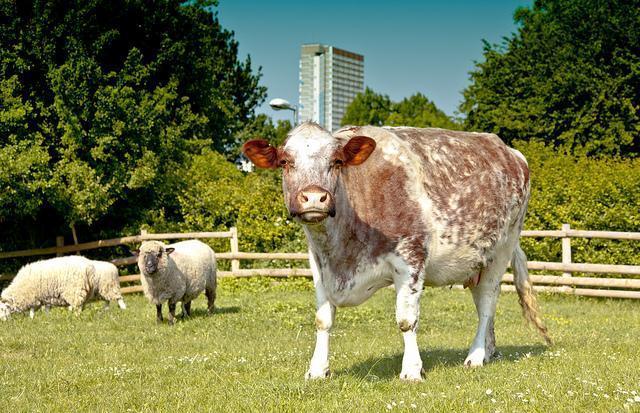How many sheep are in the picture?
Give a very brief answer. 2. How many motorcycles are there?
Give a very brief answer. 0. 